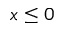<formula> <loc_0><loc_0><loc_500><loc_500>x \leq 0</formula> 